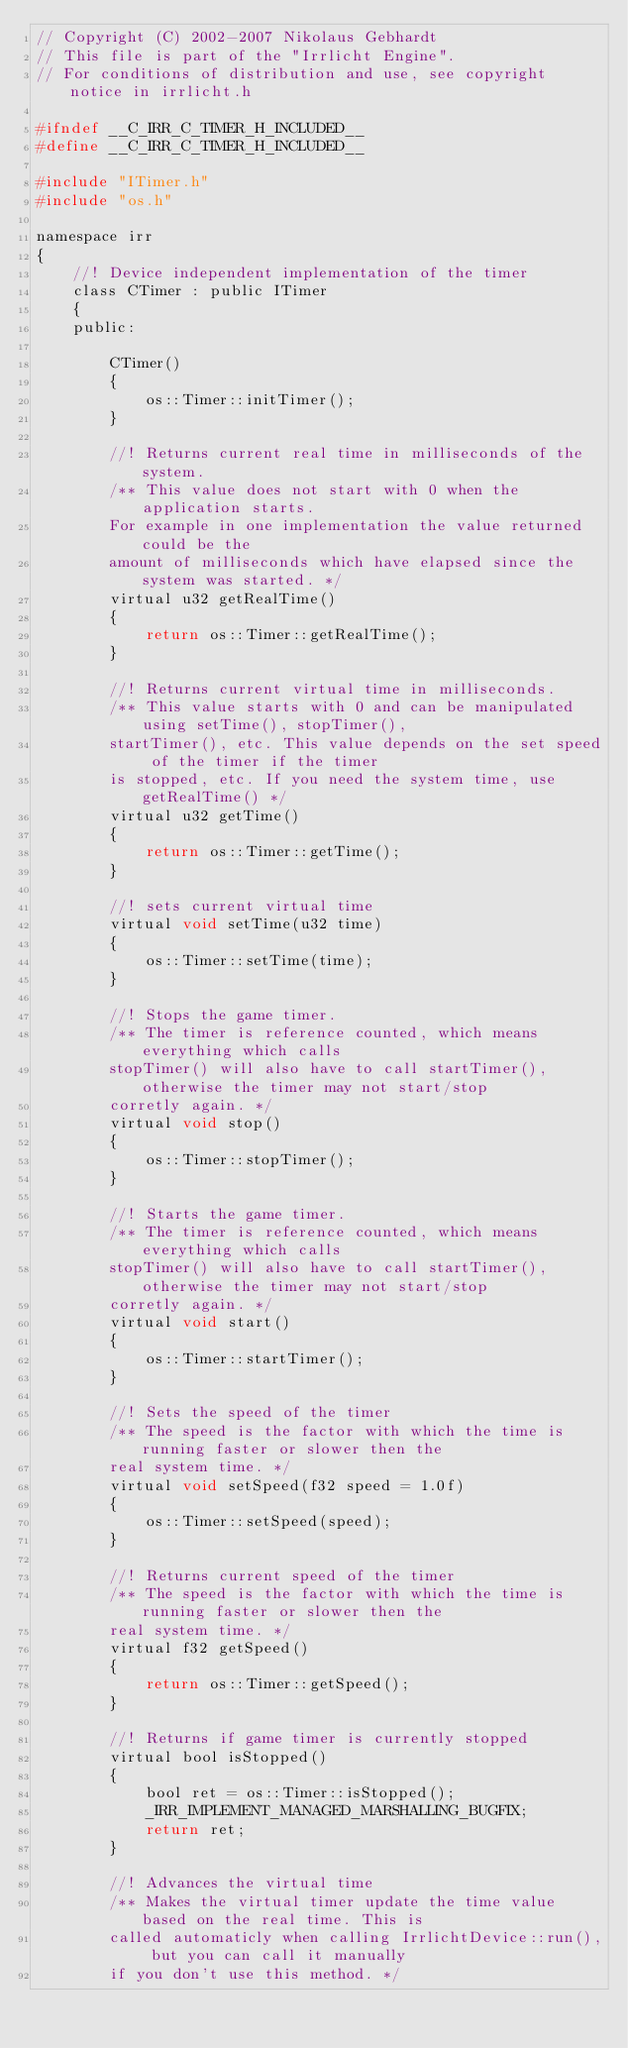<code> <loc_0><loc_0><loc_500><loc_500><_C_>// Copyright (C) 2002-2007 Nikolaus Gebhardt
// This file is part of the "Irrlicht Engine".
// For conditions of distribution and use, see copyright notice in irrlicht.h

#ifndef __C_IRR_C_TIMER_H_INCLUDED__
#define __C_IRR_C_TIMER_H_INCLUDED__

#include "ITimer.h"
#include "os.h"

namespace irr
{
	//! Device independent implementation of the timer
	class CTimer : public ITimer
	{
	public:

		CTimer()
		{
			os::Timer::initTimer();
		}

		//! Returns current real time in milliseconds of the system. 
		/** This value does not start with 0 when the application starts.
		For example in one implementation the value returned could be the 
		amount of milliseconds which have elapsed since the system was started. */
		virtual u32 getRealTime()
		{
			return os::Timer::getRealTime();
		}

		//! Returns current virtual time in milliseconds. 
		/** This value starts with 0 and can be manipulated using setTime(), stopTimer(),
		startTimer(), etc. This value depends on the set speed of the timer if the timer 
		is stopped, etc. If you need the system time, use getRealTime() */
		virtual u32 getTime()
		{
			return os::Timer::getTime();
		}

		//! sets current virtual time
		virtual void setTime(u32 time)
		{
			os::Timer::setTime(time);
		}

		//! Stops the game timer. 
		/** The timer is reference counted, which means everything which calls 
		stopTimer() will also have to call startTimer(), otherwise the timer may not start/stop
		corretly again. */
		virtual void stop()
		{
			os::Timer::stopTimer();
		}

		//! Starts the game timer.
		/** The timer is reference counted, which means everything which calls 
		stopTimer() will also have to call startTimer(), otherwise the timer may not start/stop
		corretly again. */
		virtual void start()
		{
			os::Timer::startTimer();
		}

		//! Sets the speed of the timer
		/** The speed is the factor with which the time is running faster or slower then the
		real system time. */
		virtual void setSpeed(f32 speed = 1.0f)
		{
			os::Timer::setSpeed(speed);
		}

		//! Returns current speed of the timer
		/** The speed is the factor with which the time is running faster or slower then the
		real system time. */
		virtual f32 getSpeed()
		{
			return os::Timer::getSpeed();
		}

		//! Returns if game timer is currently stopped
		virtual bool isStopped()
		{
			bool ret = os::Timer::isStopped();
			_IRR_IMPLEMENT_MANAGED_MARSHALLING_BUGFIX;
			return ret;
		}

		//! Advances the virtual time
		/** Makes the virtual timer update the time value based on the real time. This is
		called automaticly when calling IrrlichtDevice::run(), but you can call it manually
		if you don't use this method. */</code> 